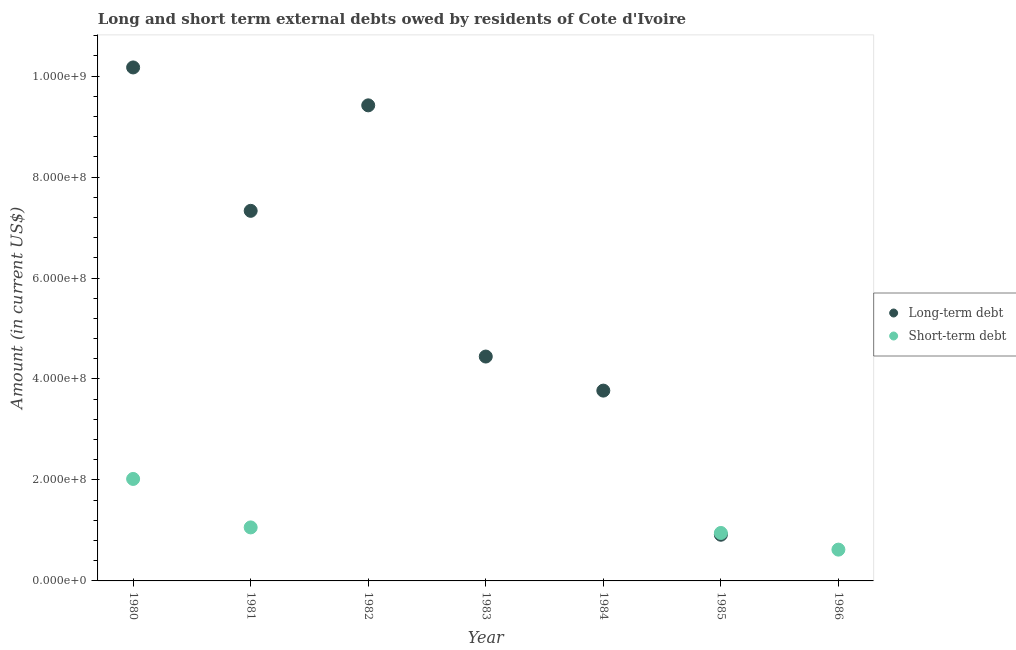How many different coloured dotlines are there?
Provide a succinct answer. 2. Across all years, what is the maximum long-term debts owed by residents?
Your answer should be very brief. 1.02e+09. What is the total short-term debts owed by residents in the graph?
Make the answer very short. 4.65e+08. What is the difference between the long-term debts owed by residents in 1982 and that in 1983?
Provide a short and direct response. 4.98e+08. What is the difference between the short-term debts owed by residents in 1985 and the long-term debts owed by residents in 1982?
Give a very brief answer. -8.47e+08. What is the average long-term debts owed by residents per year?
Provide a short and direct response. 5.15e+08. In the year 1980, what is the difference between the short-term debts owed by residents and long-term debts owed by residents?
Your answer should be very brief. -8.15e+08. What is the ratio of the short-term debts owed by residents in 1985 to that in 1986?
Offer a terse response. 1.53. What is the difference between the highest and the second highest long-term debts owed by residents?
Provide a succinct answer. 7.51e+07. What is the difference between the highest and the lowest short-term debts owed by residents?
Ensure brevity in your answer.  2.02e+08. Is the sum of the long-term debts owed by residents in 1981 and 1983 greater than the maximum short-term debts owed by residents across all years?
Keep it short and to the point. Yes. Does the short-term debts owed by residents monotonically increase over the years?
Your answer should be very brief. No. How many dotlines are there?
Offer a very short reply. 2. Does the graph contain any zero values?
Your answer should be very brief. Yes. Where does the legend appear in the graph?
Make the answer very short. Center right. How many legend labels are there?
Your answer should be compact. 2. What is the title of the graph?
Your response must be concise. Long and short term external debts owed by residents of Cote d'Ivoire. Does "Urban Population" appear as one of the legend labels in the graph?
Your answer should be compact. No. What is the label or title of the X-axis?
Your response must be concise. Year. What is the label or title of the Y-axis?
Ensure brevity in your answer.  Amount (in current US$). What is the Amount (in current US$) in Long-term debt in 1980?
Provide a short and direct response. 1.02e+09. What is the Amount (in current US$) of Short-term debt in 1980?
Provide a succinct answer. 2.02e+08. What is the Amount (in current US$) of Long-term debt in 1981?
Provide a short and direct response. 7.33e+08. What is the Amount (in current US$) in Short-term debt in 1981?
Offer a terse response. 1.06e+08. What is the Amount (in current US$) in Long-term debt in 1982?
Provide a short and direct response. 9.42e+08. What is the Amount (in current US$) in Short-term debt in 1982?
Your response must be concise. 0. What is the Amount (in current US$) in Long-term debt in 1983?
Offer a very short reply. 4.44e+08. What is the Amount (in current US$) of Long-term debt in 1984?
Keep it short and to the point. 3.77e+08. What is the Amount (in current US$) of Short-term debt in 1984?
Provide a short and direct response. 0. What is the Amount (in current US$) of Long-term debt in 1985?
Provide a short and direct response. 9.15e+07. What is the Amount (in current US$) of Short-term debt in 1985?
Offer a very short reply. 9.50e+07. What is the Amount (in current US$) in Short-term debt in 1986?
Keep it short and to the point. 6.20e+07. Across all years, what is the maximum Amount (in current US$) of Long-term debt?
Keep it short and to the point. 1.02e+09. Across all years, what is the maximum Amount (in current US$) in Short-term debt?
Keep it short and to the point. 2.02e+08. What is the total Amount (in current US$) of Long-term debt in the graph?
Keep it short and to the point. 3.61e+09. What is the total Amount (in current US$) in Short-term debt in the graph?
Your answer should be very brief. 4.65e+08. What is the difference between the Amount (in current US$) in Long-term debt in 1980 and that in 1981?
Offer a very short reply. 2.84e+08. What is the difference between the Amount (in current US$) in Short-term debt in 1980 and that in 1981?
Keep it short and to the point. 9.60e+07. What is the difference between the Amount (in current US$) in Long-term debt in 1980 and that in 1982?
Offer a very short reply. 7.51e+07. What is the difference between the Amount (in current US$) of Long-term debt in 1980 and that in 1983?
Offer a very short reply. 5.73e+08. What is the difference between the Amount (in current US$) of Long-term debt in 1980 and that in 1984?
Make the answer very short. 6.40e+08. What is the difference between the Amount (in current US$) of Long-term debt in 1980 and that in 1985?
Your response must be concise. 9.26e+08. What is the difference between the Amount (in current US$) in Short-term debt in 1980 and that in 1985?
Offer a terse response. 1.07e+08. What is the difference between the Amount (in current US$) in Short-term debt in 1980 and that in 1986?
Give a very brief answer. 1.40e+08. What is the difference between the Amount (in current US$) in Long-term debt in 1981 and that in 1982?
Your answer should be compact. -2.09e+08. What is the difference between the Amount (in current US$) of Long-term debt in 1981 and that in 1983?
Offer a very short reply. 2.89e+08. What is the difference between the Amount (in current US$) of Long-term debt in 1981 and that in 1984?
Offer a very short reply. 3.56e+08. What is the difference between the Amount (in current US$) of Long-term debt in 1981 and that in 1985?
Ensure brevity in your answer.  6.42e+08. What is the difference between the Amount (in current US$) in Short-term debt in 1981 and that in 1985?
Ensure brevity in your answer.  1.10e+07. What is the difference between the Amount (in current US$) of Short-term debt in 1981 and that in 1986?
Keep it short and to the point. 4.40e+07. What is the difference between the Amount (in current US$) of Long-term debt in 1982 and that in 1983?
Give a very brief answer. 4.98e+08. What is the difference between the Amount (in current US$) of Long-term debt in 1982 and that in 1984?
Provide a succinct answer. 5.65e+08. What is the difference between the Amount (in current US$) in Long-term debt in 1982 and that in 1985?
Your answer should be compact. 8.51e+08. What is the difference between the Amount (in current US$) of Long-term debt in 1983 and that in 1984?
Offer a terse response. 6.75e+07. What is the difference between the Amount (in current US$) of Long-term debt in 1983 and that in 1985?
Provide a succinct answer. 3.53e+08. What is the difference between the Amount (in current US$) in Long-term debt in 1984 and that in 1985?
Provide a short and direct response. 2.85e+08. What is the difference between the Amount (in current US$) of Short-term debt in 1985 and that in 1986?
Provide a short and direct response. 3.30e+07. What is the difference between the Amount (in current US$) in Long-term debt in 1980 and the Amount (in current US$) in Short-term debt in 1981?
Provide a succinct answer. 9.11e+08. What is the difference between the Amount (in current US$) of Long-term debt in 1980 and the Amount (in current US$) of Short-term debt in 1985?
Keep it short and to the point. 9.22e+08. What is the difference between the Amount (in current US$) of Long-term debt in 1980 and the Amount (in current US$) of Short-term debt in 1986?
Offer a terse response. 9.55e+08. What is the difference between the Amount (in current US$) of Long-term debt in 1981 and the Amount (in current US$) of Short-term debt in 1985?
Provide a succinct answer. 6.38e+08. What is the difference between the Amount (in current US$) in Long-term debt in 1981 and the Amount (in current US$) in Short-term debt in 1986?
Keep it short and to the point. 6.71e+08. What is the difference between the Amount (in current US$) of Long-term debt in 1982 and the Amount (in current US$) of Short-term debt in 1985?
Offer a very short reply. 8.47e+08. What is the difference between the Amount (in current US$) of Long-term debt in 1982 and the Amount (in current US$) of Short-term debt in 1986?
Your answer should be very brief. 8.80e+08. What is the difference between the Amount (in current US$) of Long-term debt in 1983 and the Amount (in current US$) of Short-term debt in 1985?
Your answer should be very brief. 3.49e+08. What is the difference between the Amount (in current US$) in Long-term debt in 1983 and the Amount (in current US$) in Short-term debt in 1986?
Offer a very short reply. 3.82e+08. What is the difference between the Amount (in current US$) of Long-term debt in 1984 and the Amount (in current US$) of Short-term debt in 1985?
Your answer should be very brief. 2.82e+08. What is the difference between the Amount (in current US$) of Long-term debt in 1984 and the Amount (in current US$) of Short-term debt in 1986?
Provide a succinct answer. 3.15e+08. What is the difference between the Amount (in current US$) of Long-term debt in 1985 and the Amount (in current US$) of Short-term debt in 1986?
Make the answer very short. 2.95e+07. What is the average Amount (in current US$) in Long-term debt per year?
Provide a succinct answer. 5.15e+08. What is the average Amount (in current US$) in Short-term debt per year?
Your response must be concise. 6.64e+07. In the year 1980, what is the difference between the Amount (in current US$) in Long-term debt and Amount (in current US$) in Short-term debt?
Ensure brevity in your answer.  8.15e+08. In the year 1981, what is the difference between the Amount (in current US$) of Long-term debt and Amount (in current US$) of Short-term debt?
Provide a succinct answer. 6.27e+08. In the year 1985, what is the difference between the Amount (in current US$) of Long-term debt and Amount (in current US$) of Short-term debt?
Your answer should be very brief. -3.50e+06. What is the ratio of the Amount (in current US$) of Long-term debt in 1980 to that in 1981?
Your answer should be compact. 1.39. What is the ratio of the Amount (in current US$) of Short-term debt in 1980 to that in 1981?
Keep it short and to the point. 1.91. What is the ratio of the Amount (in current US$) of Long-term debt in 1980 to that in 1982?
Ensure brevity in your answer.  1.08. What is the ratio of the Amount (in current US$) of Long-term debt in 1980 to that in 1983?
Make the answer very short. 2.29. What is the ratio of the Amount (in current US$) of Long-term debt in 1980 to that in 1984?
Offer a very short reply. 2.7. What is the ratio of the Amount (in current US$) in Long-term debt in 1980 to that in 1985?
Provide a short and direct response. 11.12. What is the ratio of the Amount (in current US$) in Short-term debt in 1980 to that in 1985?
Your answer should be compact. 2.13. What is the ratio of the Amount (in current US$) of Short-term debt in 1980 to that in 1986?
Offer a terse response. 3.26. What is the ratio of the Amount (in current US$) in Long-term debt in 1981 to that in 1982?
Your response must be concise. 0.78. What is the ratio of the Amount (in current US$) in Long-term debt in 1981 to that in 1983?
Ensure brevity in your answer.  1.65. What is the ratio of the Amount (in current US$) of Long-term debt in 1981 to that in 1984?
Ensure brevity in your answer.  1.94. What is the ratio of the Amount (in current US$) of Long-term debt in 1981 to that in 1985?
Provide a succinct answer. 8.01. What is the ratio of the Amount (in current US$) in Short-term debt in 1981 to that in 1985?
Your answer should be very brief. 1.12. What is the ratio of the Amount (in current US$) of Short-term debt in 1981 to that in 1986?
Your answer should be compact. 1.71. What is the ratio of the Amount (in current US$) of Long-term debt in 1982 to that in 1983?
Keep it short and to the point. 2.12. What is the ratio of the Amount (in current US$) in Long-term debt in 1982 to that in 1984?
Ensure brevity in your answer.  2.5. What is the ratio of the Amount (in current US$) in Long-term debt in 1982 to that in 1985?
Give a very brief answer. 10.3. What is the ratio of the Amount (in current US$) in Long-term debt in 1983 to that in 1984?
Offer a terse response. 1.18. What is the ratio of the Amount (in current US$) of Long-term debt in 1983 to that in 1985?
Offer a terse response. 4.86. What is the ratio of the Amount (in current US$) of Long-term debt in 1984 to that in 1985?
Your answer should be very brief. 4.12. What is the ratio of the Amount (in current US$) of Short-term debt in 1985 to that in 1986?
Give a very brief answer. 1.53. What is the difference between the highest and the second highest Amount (in current US$) of Long-term debt?
Your answer should be compact. 7.51e+07. What is the difference between the highest and the second highest Amount (in current US$) of Short-term debt?
Your response must be concise. 9.60e+07. What is the difference between the highest and the lowest Amount (in current US$) of Long-term debt?
Your answer should be compact. 1.02e+09. What is the difference between the highest and the lowest Amount (in current US$) of Short-term debt?
Provide a succinct answer. 2.02e+08. 